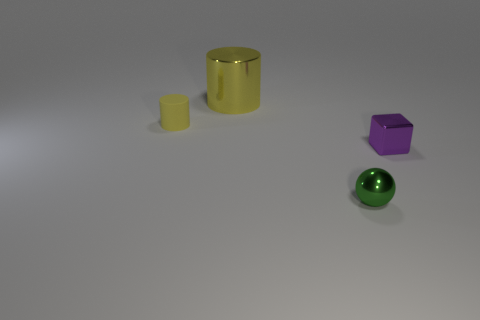Add 3 small green things. How many objects exist? 7 Subtract all balls. How many objects are left? 3 Add 2 small brown matte objects. How many small brown matte objects exist? 2 Subtract 0 blue cubes. How many objects are left? 4 Subtract all yellow objects. Subtract all yellow rubber cylinders. How many objects are left? 1 Add 1 green metal balls. How many green metal balls are left? 2 